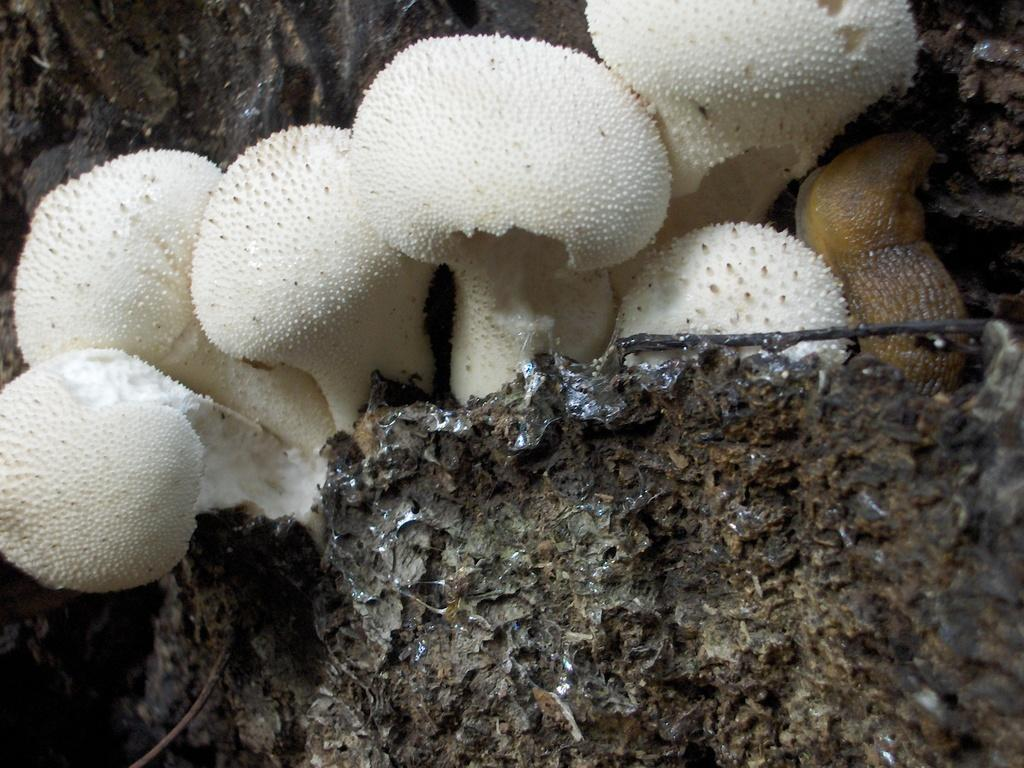What type of fungi can be seen in the image? There are mushrooms in the image. What is the color of the mushrooms? The mushrooms are white in color. Can you describe the brown object in the image? There is a brown color thing in the image, but its specific nature is not mentioned in the facts. How many sisters are visible in the image? There are no sisters present in the image; it features mushrooms and a brown object. 